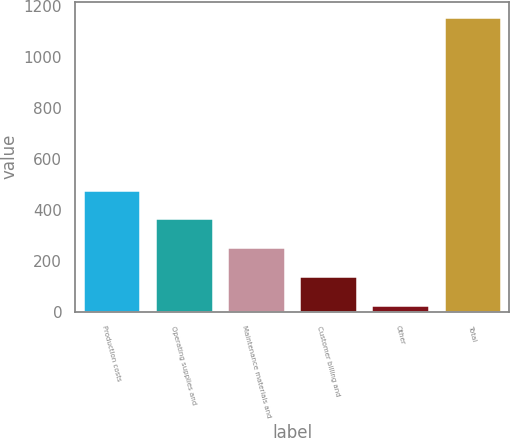Convert chart to OTSL. <chart><loc_0><loc_0><loc_500><loc_500><bar_chart><fcel>Production costs<fcel>Operating supplies and<fcel>Maintenance materials and<fcel>Customer billing and<fcel>Other<fcel>Total<nl><fcel>479.8<fcel>366.6<fcel>253.4<fcel>140.2<fcel>27<fcel>1159<nl></chart> 